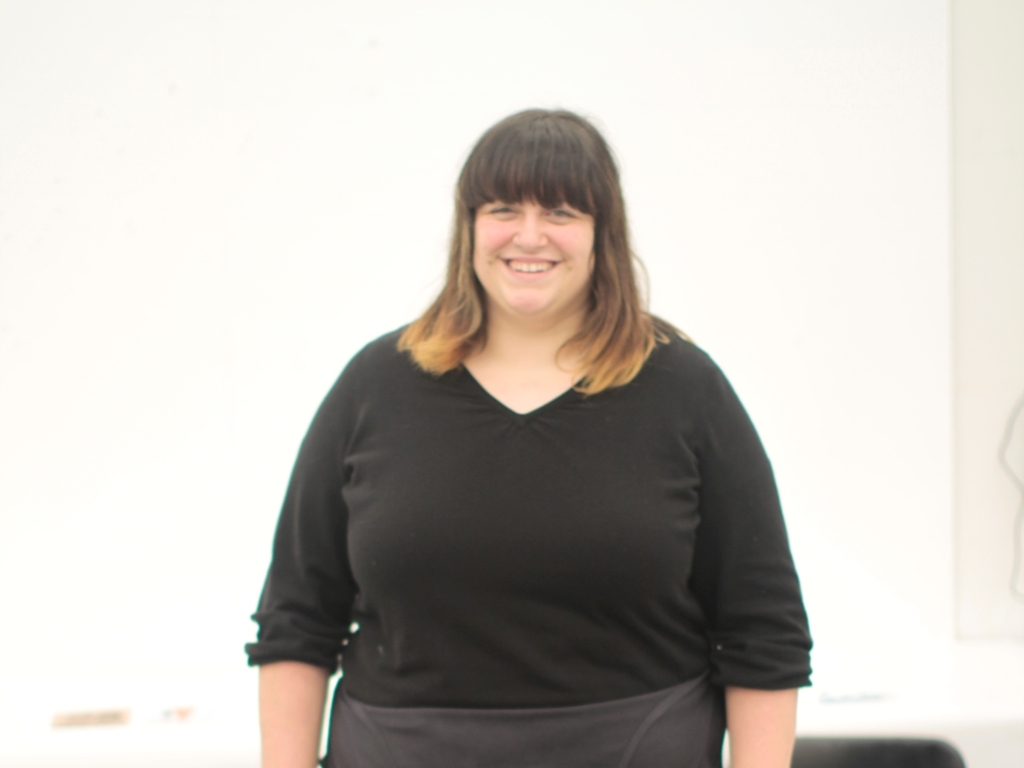Can you describe the setting surrounding the person in this image? The background of the image is minimalistic and brightly lit, suggesting a studio setup or a space designed for indoor photography sessions. There is little to no distracting elements, making the individual the clear focal point of this image. What kind of mood does the image convey? The woman's smile and relaxed posture provide a cheerful and positive ambiance to the image. Her confident stance, paired with the clean and uncluttered background, exudes a sense of simplicity and openness. 